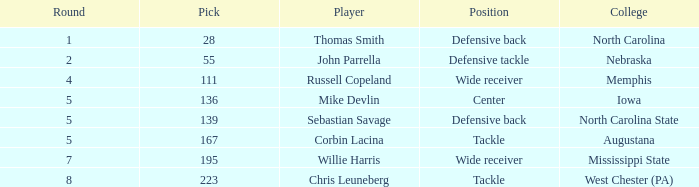What is the combined amount of a round that includes a 55 pick? 2.0. Give me the full table as a dictionary. {'header': ['Round', 'Pick', 'Player', 'Position', 'College'], 'rows': [['1', '28', 'Thomas Smith', 'Defensive back', 'North Carolina'], ['2', '55', 'John Parrella', 'Defensive tackle', 'Nebraska'], ['4', '111', 'Russell Copeland', 'Wide receiver', 'Memphis'], ['5', '136', 'Mike Devlin', 'Center', 'Iowa'], ['5', '139', 'Sebastian Savage', 'Defensive back', 'North Carolina State'], ['5', '167', 'Corbin Lacina', 'Tackle', 'Augustana'], ['7', '195', 'Willie Harris', 'Wide receiver', 'Mississippi State'], ['8', '223', 'Chris Leuneberg', 'Tackle', 'West Chester (PA)']]} 